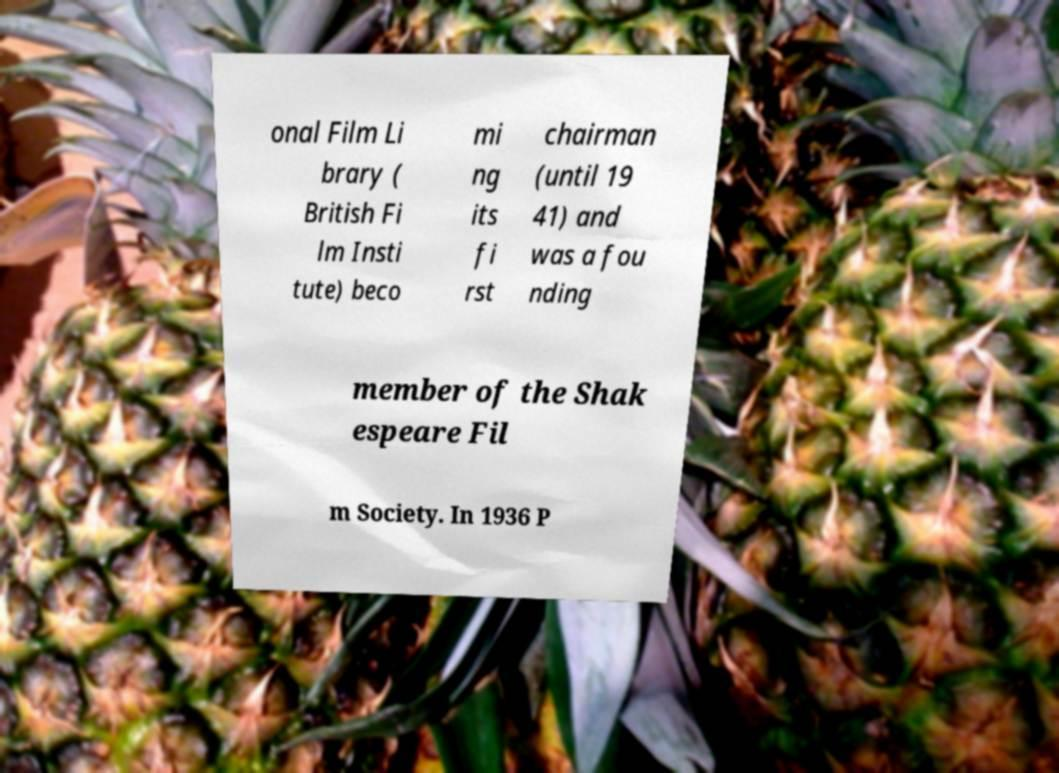Can you read and provide the text displayed in the image?This photo seems to have some interesting text. Can you extract and type it out for me? onal Film Li brary ( British Fi lm Insti tute) beco mi ng its fi rst chairman (until 19 41) and was a fou nding member of the Shak espeare Fil m Society. In 1936 P 